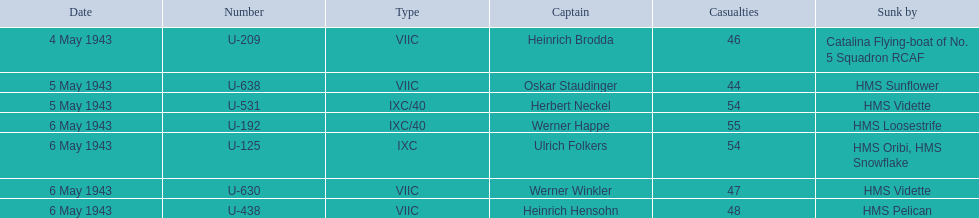Who are the various captains? Heinrich Brodda, Oskar Staudinger, Herbert Neckel, Werner Happe, Ulrich Folkers, Werner Winkler, Heinrich Hensohn. What factors resulted in the sinking of each captain? Catalina Flying-boat of No. 5 Squadron RCAF, HMS Sunflower, HMS Vidette, HMS Loosestrife, HMS Oribi, HMS Snowflake, HMS Vidette, HMS Pelican. Which captain was sunk by the hms pelican? Heinrich Hensohn. 